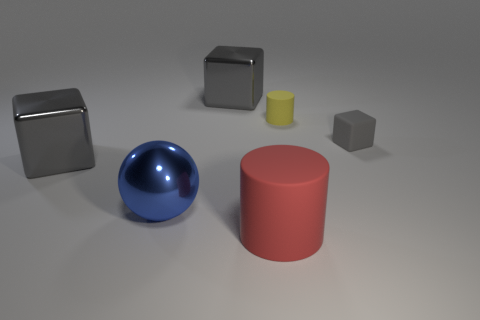What material is the gray block behind the cylinder that is behind the big matte object made of?
Make the answer very short. Metal. Does the large shiny thing on the left side of the large blue metal thing have the same shape as the small gray matte object?
Your answer should be compact. Yes. Are there more big metal spheres that are to the right of the large red thing than small blue shiny cylinders?
Keep it short and to the point. No. Is there any other thing that is the same material as the large blue ball?
Provide a succinct answer. Yes. How many balls are either tiny yellow things or small things?
Your answer should be very brief. 0. There is a large object that is to the right of the metallic object behind the yellow object; what is its color?
Your answer should be very brief. Red. Do the tiny matte cylinder and the large cube that is on the right side of the blue sphere have the same color?
Provide a succinct answer. No. The cube that is the same material as the big cylinder is what size?
Your response must be concise. Small. Does the ball have the same color as the large rubber cylinder?
Provide a succinct answer. No. Are there any big red matte cylinders behind the metal block behind the gray thing that is in front of the small cube?
Your response must be concise. No. 